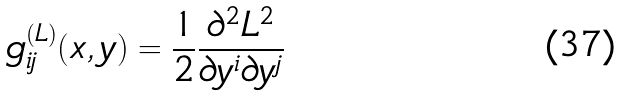<formula> <loc_0><loc_0><loc_500><loc_500>g _ { i j } ^ { ( L ) } ( x , y ) = \frac { 1 } { 2 } \frac { \partial ^ { 2 } L ^ { 2 } } { \partial y ^ { i } \partial y ^ { j } }</formula> 